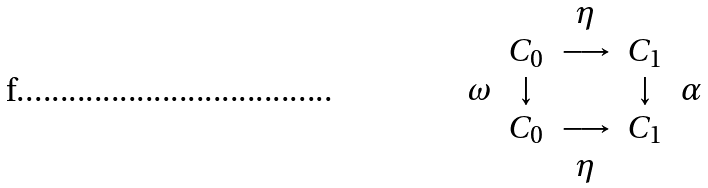<formula> <loc_0><loc_0><loc_500><loc_500>\begin{array} { c c c c c } & & \eta & & \\ & C _ { 0 } & \longrightarrow & C _ { 1 } & \\ \omega & \downarrow & & \downarrow & \alpha \\ & C _ { 0 } & \longrightarrow & C _ { 1 } & \\ & & \eta & & \end{array}</formula> 